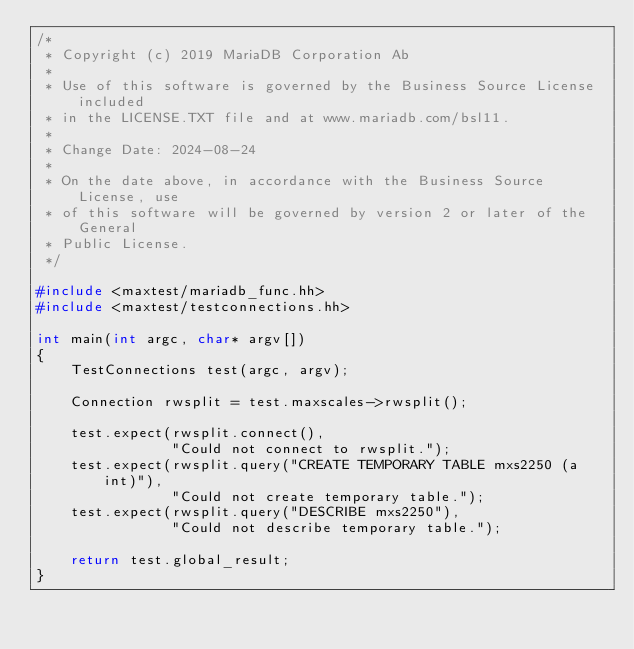<code> <loc_0><loc_0><loc_500><loc_500><_C++_>/*
 * Copyright (c) 2019 MariaDB Corporation Ab
 *
 * Use of this software is governed by the Business Source License included
 * in the LICENSE.TXT file and at www.mariadb.com/bsl11.
 *
 * Change Date: 2024-08-24
 *
 * On the date above, in accordance with the Business Source License, use
 * of this software will be governed by version 2 or later of the General
 * Public License.
 */

#include <maxtest/mariadb_func.hh>
#include <maxtest/testconnections.hh>

int main(int argc, char* argv[])
{
    TestConnections test(argc, argv);

    Connection rwsplit = test.maxscales->rwsplit();

    test.expect(rwsplit.connect(),
                "Could not connect to rwsplit.");
    test.expect(rwsplit.query("CREATE TEMPORARY TABLE mxs2250 (a int)"),
                "Could not create temporary table.");
    test.expect(rwsplit.query("DESCRIBE mxs2250"),
                "Could not describe temporary table.");

    return test.global_result;
}
</code> 